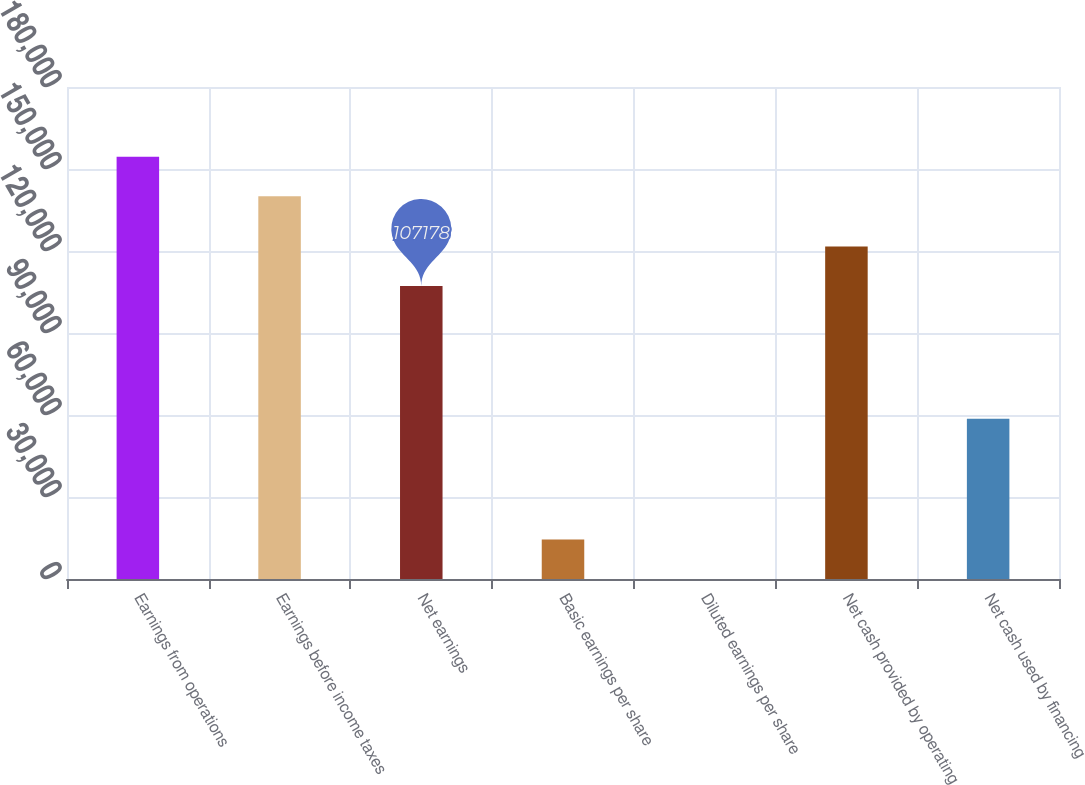Convert chart to OTSL. <chart><loc_0><loc_0><loc_500><loc_500><bar_chart><fcel>Earnings from operations<fcel>Earnings before income taxes<fcel>Net earnings<fcel>Basic earnings per share<fcel>Diluted earnings per share<fcel>Net cash provided by operating<fcel>Net cash used by financing<nl><fcel>154453<fcel>140017<fcel>107178<fcel>14437.4<fcel>1.4<fcel>121614<fcel>58610<nl></chart> 